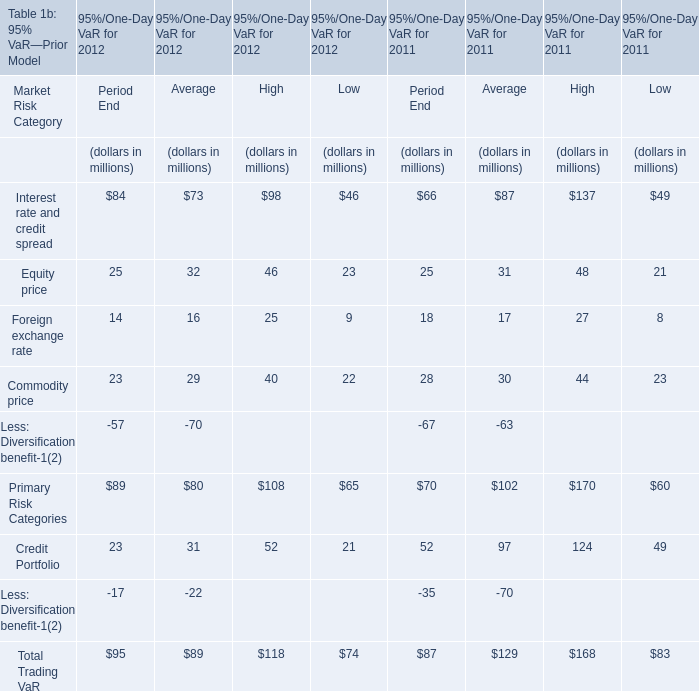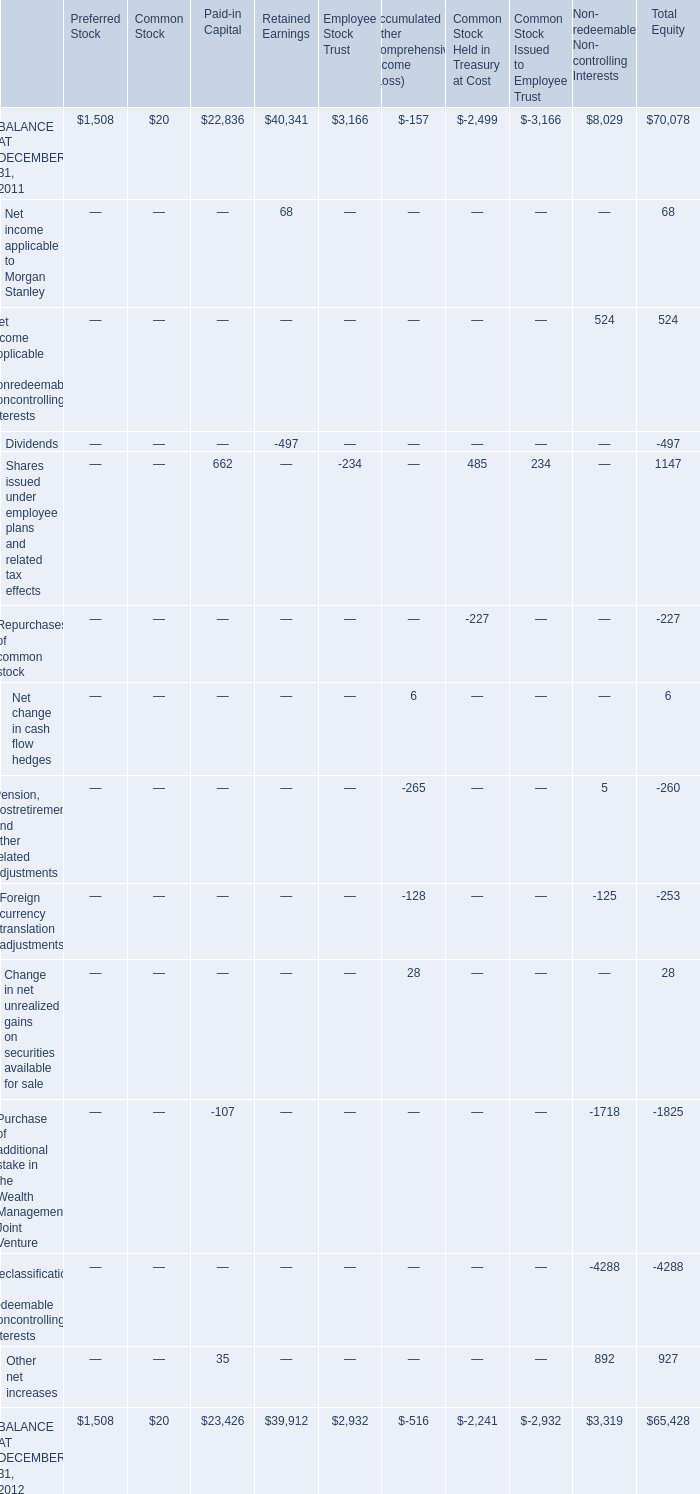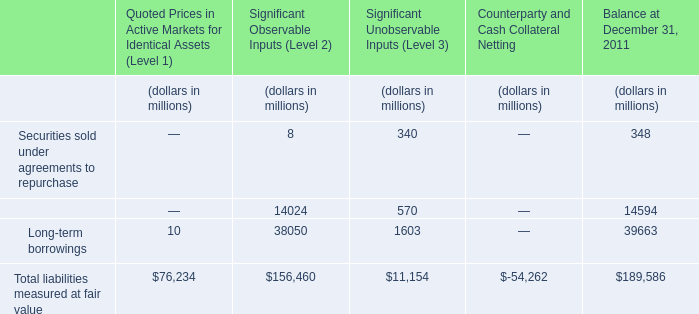What was the total amount of elements for Period End greater than 80 in 2012 ? (in million) 
Computations: ((84 + 89) + 95)
Answer: 268.0. 